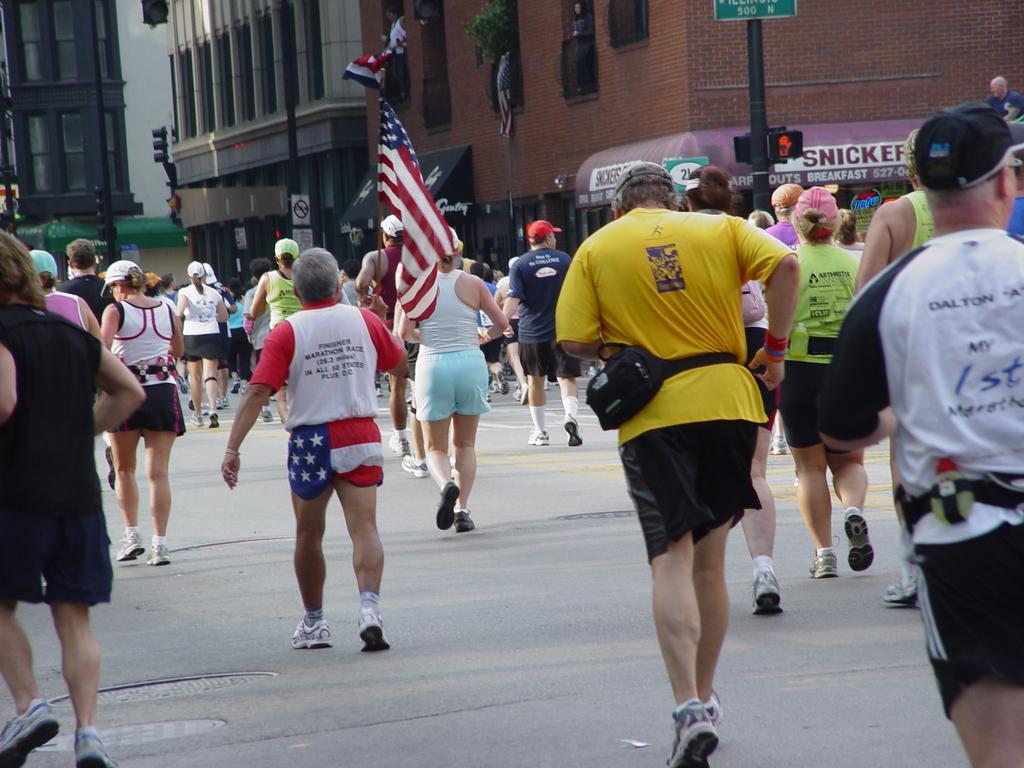How would you summarize this image in a sentence or two? In the picture we can see many people are running on the road, some are holding flag and in the background, we can see some buildings and near to it we can see some poles and traffic light. 